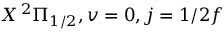<formula> <loc_0><loc_0><loc_500><loc_500>X \, ^ { 2 } \Pi _ { 1 / 2 } , v = 0 , j = 1 / 2 f</formula> 